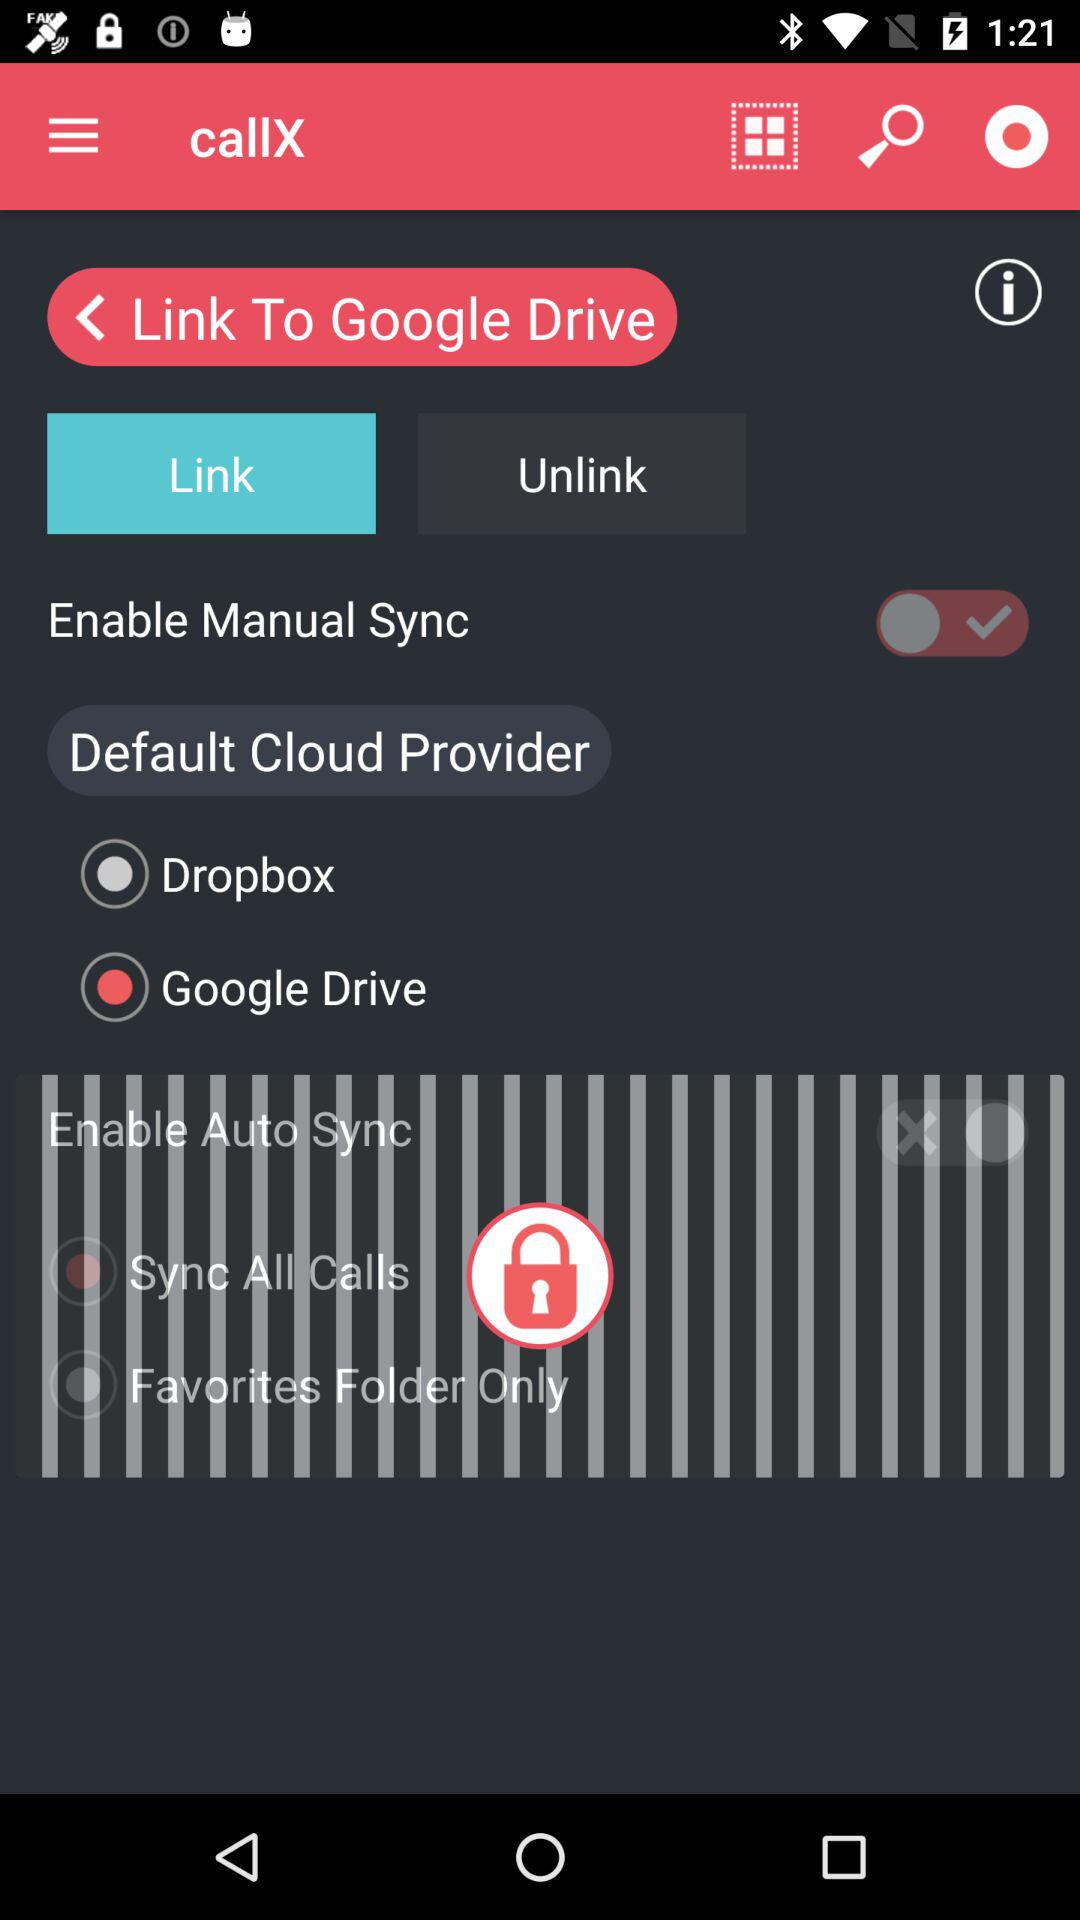Which option has been selected? The selected option is "Link". 